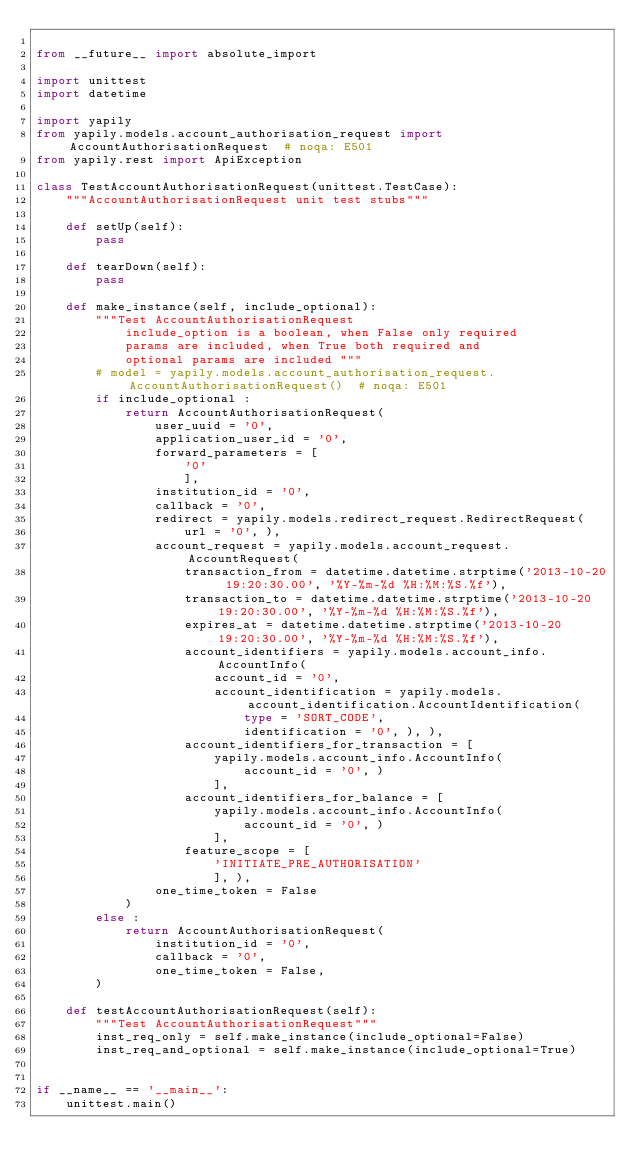Convert code to text. <code><loc_0><loc_0><loc_500><loc_500><_Python_>
from __future__ import absolute_import

import unittest
import datetime

import yapily
from yapily.models.account_authorisation_request import AccountAuthorisationRequest  # noqa: E501
from yapily.rest import ApiException

class TestAccountAuthorisationRequest(unittest.TestCase):
    """AccountAuthorisationRequest unit test stubs"""

    def setUp(self):
        pass

    def tearDown(self):
        pass

    def make_instance(self, include_optional):
        """Test AccountAuthorisationRequest
            include_option is a boolean, when False only required
            params are included, when True both required and
            optional params are included """
        # model = yapily.models.account_authorisation_request.AccountAuthorisationRequest()  # noqa: E501
        if include_optional :
            return AccountAuthorisationRequest(
                user_uuid = '0', 
                application_user_id = '0', 
                forward_parameters = [
                    '0'
                    ], 
                institution_id = '0', 
                callback = '0', 
                redirect = yapily.models.redirect_request.RedirectRequest(
                    url = '0', ), 
                account_request = yapily.models.account_request.AccountRequest(
                    transaction_from = datetime.datetime.strptime('2013-10-20 19:20:30.00', '%Y-%m-%d %H:%M:%S.%f'), 
                    transaction_to = datetime.datetime.strptime('2013-10-20 19:20:30.00', '%Y-%m-%d %H:%M:%S.%f'), 
                    expires_at = datetime.datetime.strptime('2013-10-20 19:20:30.00', '%Y-%m-%d %H:%M:%S.%f'), 
                    account_identifiers = yapily.models.account_info.AccountInfo(
                        account_id = '0', 
                        account_identification = yapily.models.account_identification.AccountIdentification(
                            type = 'SORT_CODE', 
                            identification = '0', ), ), 
                    account_identifiers_for_transaction = [
                        yapily.models.account_info.AccountInfo(
                            account_id = '0', )
                        ], 
                    account_identifiers_for_balance = [
                        yapily.models.account_info.AccountInfo(
                            account_id = '0', )
                        ], 
                    feature_scope = [
                        'INITIATE_PRE_AUTHORISATION'
                        ], ), 
                one_time_token = False
            )
        else :
            return AccountAuthorisationRequest(
                institution_id = '0',
                callback = '0',
                one_time_token = False,
        )

    def testAccountAuthorisationRequest(self):
        """Test AccountAuthorisationRequest"""
        inst_req_only = self.make_instance(include_optional=False)
        inst_req_and_optional = self.make_instance(include_optional=True)


if __name__ == '__main__':
    unittest.main()
</code> 